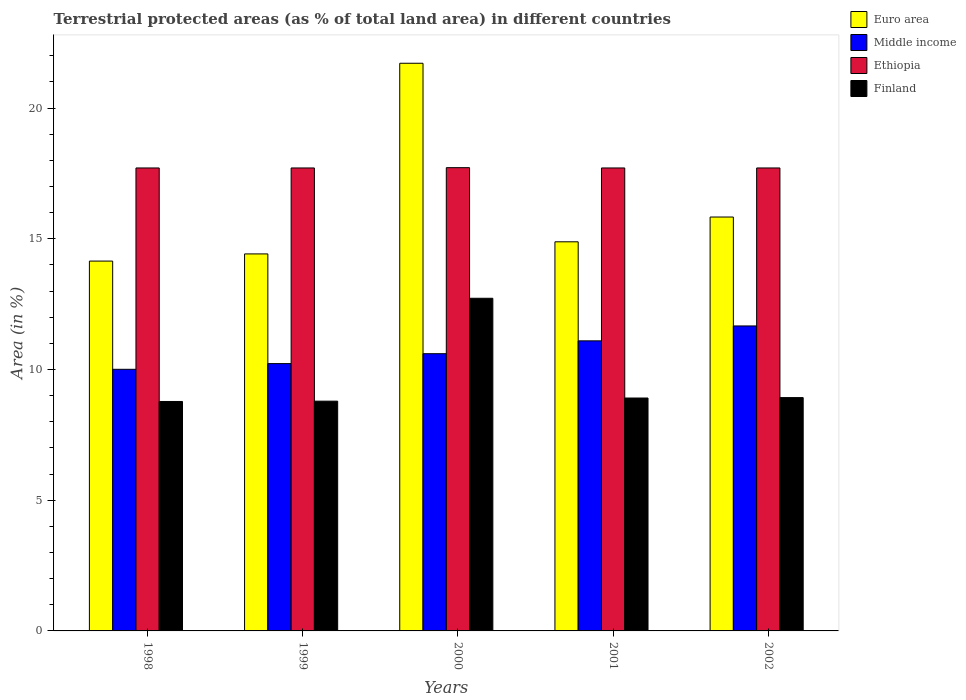How many different coloured bars are there?
Provide a short and direct response. 4. Are the number of bars on each tick of the X-axis equal?
Make the answer very short. Yes. How many bars are there on the 4th tick from the right?
Ensure brevity in your answer.  4. In how many cases, is the number of bars for a given year not equal to the number of legend labels?
Provide a short and direct response. 0. What is the percentage of terrestrial protected land in Ethiopia in 2002?
Provide a succinct answer. 17.71. Across all years, what is the maximum percentage of terrestrial protected land in Middle income?
Offer a terse response. 11.67. Across all years, what is the minimum percentage of terrestrial protected land in Finland?
Offer a terse response. 8.78. In which year was the percentage of terrestrial protected land in Middle income minimum?
Provide a short and direct response. 1998. What is the total percentage of terrestrial protected land in Ethiopia in the graph?
Ensure brevity in your answer.  88.57. What is the difference between the percentage of terrestrial protected land in Ethiopia in 2000 and that in 2002?
Your answer should be very brief. 0.01. What is the difference between the percentage of terrestrial protected land in Ethiopia in 2001 and the percentage of terrestrial protected land in Finland in 2002?
Keep it short and to the point. 8.79. What is the average percentage of terrestrial protected land in Ethiopia per year?
Give a very brief answer. 17.71. In the year 2001, what is the difference between the percentage of terrestrial protected land in Middle income and percentage of terrestrial protected land in Euro area?
Give a very brief answer. -3.79. In how many years, is the percentage of terrestrial protected land in Finland greater than 3 %?
Provide a short and direct response. 5. What is the ratio of the percentage of terrestrial protected land in Middle income in 1998 to that in 2002?
Your answer should be very brief. 0.86. Is the percentage of terrestrial protected land in Euro area in 1998 less than that in 2001?
Your answer should be compact. Yes. Is the difference between the percentage of terrestrial protected land in Middle income in 1999 and 2001 greater than the difference between the percentage of terrestrial protected land in Euro area in 1999 and 2001?
Ensure brevity in your answer.  No. What is the difference between the highest and the second highest percentage of terrestrial protected land in Finland?
Your response must be concise. 3.8. What is the difference between the highest and the lowest percentage of terrestrial protected land in Ethiopia?
Offer a very short reply. 0.01. Is it the case that in every year, the sum of the percentage of terrestrial protected land in Ethiopia and percentage of terrestrial protected land in Euro area is greater than the sum of percentage of terrestrial protected land in Middle income and percentage of terrestrial protected land in Finland?
Offer a very short reply. Yes. What does the 4th bar from the left in 1998 represents?
Provide a succinct answer. Finland. Are all the bars in the graph horizontal?
Make the answer very short. No. How many years are there in the graph?
Keep it short and to the point. 5. Does the graph contain any zero values?
Provide a succinct answer. No. Does the graph contain grids?
Your answer should be very brief. No. Where does the legend appear in the graph?
Give a very brief answer. Top right. How many legend labels are there?
Provide a succinct answer. 4. How are the legend labels stacked?
Ensure brevity in your answer.  Vertical. What is the title of the graph?
Your answer should be very brief. Terrestrial protected areas (as % of total land area) in different countries. Does "Slovenia" appear as one of the legend labels in the graph?
Keep it short and to the point. No. What is the label or title of the X-axis?
Offer a very short reply. Years. What is the label or title of the Y-axis?
Your answer should be very brief. Area (in %). What is the Area (in %) of Euro area in 1998?
Your answer should be very brief. 14.15. What is the Area (in %) of Middle income in 1998?
Make the answer very short. 10.01. What is the Area (in %) of Ethiopia in 1998?
Provide a succinct answer. 17.71. What is the Area (in %) of Finland in 1998?
Offer a very short reply. 8.78. What is the Area (in %) in Euro area in 1999?
Make the answer very short. 14.42. What is the Area (in %) in Middle income in 1999?
Keep it short and to the point. 10.23. What is the Area (in %) in Ethiopia in 1999?
Provide a succinct answer. 17.71. What is the Area (in %) of Finland in 1999?
Your answer should be compact. 8.79. What is the Area (in %) of Euro area in 2000?
Offer a terse response. 21.72. What is the Area (in %) in Middle income in 2000?
Make the answer very short. 10.61. What is the Area (in %) of Ethiopia in 2000?
Offer a terse response. 17.72. What is the Area (in %) in Finland in 2000?
Give a very brief answer. 12.73. What is the Area (in %) in Euro area in 2001?
Your response must be concise. 14.89. What is the Area (in %) of Middle income in 2001?
Your answer should be very brief. 11.1. What is the Area (in %) in Ethiopia in 2001?
Ensure brevity in your answer.  17.71. What is the Area (in %) in Finland in 2001?
Give a very brief answer. 8.91. What is the Area (in %) in Euro area in 2002?
Offer a terse response. 15.83. What is the Area (in %) of Middle income in 2002?
Keep it short and to the point. 11.67. What is the Area (in %) in Ethiopia in 2002?
Ensure brevity in your answer.  17.71. What is the Area (in %) of Finland in 2002?
Ensure brevity in your answer.  8.93. Across all years, what is the maximum Area (in %) of Euro area?
Ensure brevity in your answer.  21.72. Across all years, what is the maximum Area (in %) of Middle income?
Your response must be concise. 11.67. Across all years, what is the maximum Area (in %) in Ethiopia?
Offer a very short reply. 17.72. Across all years, what is the maximum Area (in %) of Finland?
Your response must be concise. 12.73. Across all years, what is the minimum Area (in %) of Euro area?
Keep it short and to the point. 14.15. Across all years, what is the minimum Area (in %) in Middle income?
Keep it short and to the point. 10.01. Across all years, what is the minimum Area (in %) in Ethiopia?
Provide a short and direct response. 17.71. Across all years, what is the minimum Area (in %) in Finland?
Your answer should be compact. 8.78. What is the total Area (in %) of Euro area in the graph?
Give a very brief answer. 81.01. What is the total Area (in %) in Middle income in the graph?
Provide a short and direct response. 53.6. What is the total Area (in %) in Ethiopia in the graph?
Make the answer very short. 88.57. What is the total Area (in %) of Finland in the graph?
Offer a terse response. 48.13. What is the difference between the Area (in %) of Euro area in 1998 and that in 1999?
Give a very brief answer. -0.27. What is the difference between the Area (in %) in Middle income in 1998 and that in 1999?
Give a very brief answer. -0.22. What is the difference between the Area (in %) in Ethiopia in 1998 and that in 1999?
Your response must be concise. 0. What is the difference between the Area (in %) in Finland in 1998 and that in 1999?
Ensure brevity in your answer.  -0.01. What is the difference between the Area (in %) of Euro area in 1998 and that in 2000?
Offer a very short reply. -7.57. What is the difference between the Area (in %) of Middle income in 1998 and that in 2000?
Provide a short and direct response. -0.6. What is the difference between the Area (in %) of Ethiopia in 1998 and that in 2000?
Provide a succinct answer. -0.01. What is the difference between the Area (in %) in Finland in 1998 and that in 2000?
Give a very brief answer. -3.95. What is the difference between the Area (in %) of Euro area in 1998 and that in 2001?
Your answer should be very brief. -0.74. What is the difference between the Area (in %) of Middle income in 1998 and that in 2001?
Provide a succinct answer. -1.09. What is the difference between the Area (in %) of Ethiopia in 1998 and that in 2001?
Ensure brevity in your answer.  0. What is the difference between the Area (in %) of Finland in 1998 and that in 2001?
Keep it short and to the point. -0.13. What is the difference between the Area (in %) of Euro area in 1998 and that in 2002?
Provide a short and direct response. -1.69. What is the difference between the Area (in %) of Middle income in 1998 and that in 2002?
Ensure brevity in your answer.  -1.66. What is the difference between the Area (in %) in Ethiopia in 1998 and that in 2002?
Provide a succinct answer. 0. What is the difference between the Area (in %) in Finland in 1998 and that in 2002?
Make the answer very short. -0.15. What is the difference between the Area (in %) of Euro area in 1999 and that in 2000?
Provide a succinct answer. -7.29. What is the difference between the Area (in %) of Middle income in 1999 and that in 2000?
Keep it short and to the point. -0.38. What is the difference between the Area (in %) of Ethiopia in 1999 and that in 2000?
Offer a very short reply. -0.01. What is the difference between the Area (in %) in Finland in 1999 and that in 2000?
Your answer should be very brief. -3.94. What is the difference between the Area (in %) of Euro area in 1999 and that in 2001?
Ensure brevity in your answer.  -0.46. What is the difference between the Area (in %) in Middle income in 1999 and that in 2001?
Offer a terse response. -0.87. What is the difference between the Area (in %) of Ethiopia in 1999 and that in 2001?
Provide a succinct answer. 0. What is the difference between the Area (in %) of Finland in 1999 and that in 2001?
Offer a terse response. -0.12. What is the difference between the Area (in %) of Euro area in 1999 and that in 2002?
Your response must be concise. -1.41. What is the difference between the Area (in %) of Middle income in 1999 and that in 2002?
Provide a succinct answer. -1.44. What is the difference between the Area (in %) in Finland in 1999 and that in 2002?
Your response must be concise. -0.14. What is the difference between the Area (in %) of Euro area in 2000 and that in 2001?
Your answer should be compact. 6.83. What is the difference between the Area (in %) in Middle income in 2000 and that in 2001?
Ensure brevity in your answer.  -0.49. What is the difference between the Area (in %) of Ethiopia in 2000 and that in 2001?
Keep it short and to the point. 0.01. What is the difference between the Area (in %) in Finland in 2000 and that in 2001?
Give a very brief answer. 3.82. What is the difference between the Area (in %) in Euro area in 2000 and that in 2002?
Your answer should be very brief. 5.88. What is the difference between the Area (in %) in Middle income in 2000 and that in 2002?
Offer a very short reply. -1.06. What is the difference between the Area (in %) in Ethiopia in 2000 and that in 2002?
Provide a succinct answer. 0.01. What is the difference between the Area (in %) of Finland in 2000 and that in 2002?
Provide a succinct answer. 3.8. What is the difference between the Area (in %) of Euro area in 2001 and that in 2002?
Make the answer very short. -0.95. What is the difference between the Area (in %) in Middle income in 2001 and that in 2002?
Your answer should be compact. -0.57. What is the difference between the Area (in %) of Finland in 2001 and that in 2002?
Give a very brief answer. -0.02. What is the difference between the Area (in %) in Euro area in 1998 and the Area (in %) in Middle income in 1999?
Give a very brief answer. 3.92. What is the difference between the Area (in %) of Euro area in 1998 and the Area (in %) of Ethiopia in 1999?
Give a very brief answer. -3.56. What is the difference between the Area (in %) in Euro area in 1998 and the Area (in %) in Finland in 1999?
Keep it short and to the point. 5.36. What is the difference between the Area (in %) of Middle income in 1998 and the Area (in %) of Ethiopia in 1999?
Your response must be concise. -7.7. What is the difference between the Area (in %) of Middle income in 1998 and the Area (in %) of Finland in 1999?
Ensure brevity in your answer.  1.22. What is the difference between the Area (in %) of Ethiopia in 1998 and the Area (in %) of Finland in 1999?
Your answer should be compact. 8.92. What is the difference between the Area (in %) in Euro area in 1998 and the Area (in %) in Middle income in 2000?
Provide a short and direct response. 3.54. What is the difference between the Area (in %) in Euro area in 1998 and the Area (in %) in Ethiopia in 2000?
Make the answer very short. -3.57. What is the difference between the Area (in %) of Euro area in 1998 and the Area (in %) of Finland in 2000?
Offer a terse response. 1.42. What is the difference between the Area (in %) of Middle income in 1998 and the Area (in %) of Ethiopia in 2000?
Your answer should be very brief. -7.71. What is the difference between the Area (in %) of Middle income in 1998 and the Area (in %) of Finland in 2000?
Give a very brief answer. -2.72. What is the difference between the Area (in %) of Ethiopia in 1998 and the Area (in %) of Finland in 2000?
Your response must be concise. 4.99. What is the difference between the Area (in %) in Euro area in 1998 and the Area (in %) in Middle income in 2001?
Provide a short and direct response. 3.05. What is the difference between the Area (in %) of Euro area in 1998 and the Area (in %) of Ethiopia in 2001?
Provide a succinct answer. -3.56. What is the difference between the Area (in %) of Euro area in 1998 and the Area (in %) of Finland in 2001?
Offer a very short reply. 5.24. What is the difference between the Area (in %) in Middle income in 1998 and the Area (in %) in Ethiopia in 2001?
Your answer should be very brief. -7.7. What is the difference between the Area (in %) of Middle income in 1998 and the Area (in %) of Finland in 2001?
Your answer should be very brief. 1.1. What is the difference between the Area (in %) of Ethiopia in 1998 and the Area (in %) of Finland in 2001?
Provide a short and direct response. 8.8. What is the difference between the Area (in %) in Euro area in 1998 and the Area (in %) in Middle income in 2002?
Provide a succinct answer. 2.48. What is the difference between the Area (in %) of Euro area in 1998 and the Area (in %) of Ethiopia in 2002?
Keep it short and to the point. -3.56. What is the difference between the Area (in %) of Euro area in 1998 and the Area (in %) of Finland in 2002?
Your response must be concise. 5.22. What is the difference between the Area (in %) in Middle income in 1998 and the Area (in %) in Ethiopia in 2002?
Ensure brevity in your answer.  -7.7. What is the difference between the Area (in %) of Middle income in 1998 and the Area (in %) of Finland in 2002?
Make the answer very short. 1.08. What is the difference between the Area (in %) of Ethiopia in 1998 and the Area (in %) of Finland in 2002?
Give a very brief answer. 8.79. What is the difference between the Area (in %) of Euro area in 1999 and the Area (in %) of Middle income in 2000?
Offer a very short reply. 3.82. What is the difference between the Area (in %) in Euro area in 1999 and the Area (in %) in Ethiopia in 2000?
Offer a terse response. -3.3. What is the difference between the Area (in %) of Euro area in 1999 and the Area (in %) of Finland in 2000?
Provide a succinct answer. 1.7. What is the difference between the Area (in %) of Middle income in 1999 and the Area (in %) of Ethiopia in 2000?
Offer a terse response. -7.5. What is the difference between the Area (in %) of Middle income in 1999 and the Area (in %) of Finland in 2000?
Provide a short and direct response. -2.5. What is the difference between the Area (in %) of Ethiopia in 1999 and the Area (in %) of Finland in 2000?
Give a very brief answer. 4.99. What is the difference between the Area (in %) of Euro area in 1999 and the Area (in %) of Middle income in 2001?
Offer a very short reply. 3.33. What is the difference between the Area (in %) of Euro area in 1999 and the Area (in %) of Ethiopia in 2001?
Provide a short and direct response. -3.29. What is the difference between the Area (in %) in Euro area in 1999 and the Area (in %) in Finland in 2001?
Ensure brevity in your answer.  5.51. What is the difference between the Area (in %) in Middle income in 1999 and the Area (in %) in Ethiopia in 2001?
Ensure brevity in your answer.  -7.48. What is the difference between the Area (in %) in Middle income in 1999 and the Area (in %) in Finland in 2001?
Your answer should be very brief. 1.32. What is the difference between the Area (in %) in Ethiopia in 1999 and the Area (in %) in Finland in 2001?
Ensure brevity in your answer.  8.8. What is the difference between the Area (in %) in Euro area in 1999 and the Area (in %) in Middle income in 2002?
Provide a short and direct response. 2.76. What is the difference between the Area (in %) of Euro area in 1999 and the Area (in %) of Ethiopia in 2002?
Offer a very short reply. -3.29. What is the difference between the Area (in %) of Euro area in 1999 and the Area (in %) of Finland in 2002?
Your answer should be compact. 5.5. What is the difference between the Area (in %) in Middle income in 1999 and the Area (in %) in Ethiopia in 2002?
Ensure brevity in your answer.  -7.48. What is the difference between the Area (in %) of Middle income in 1999 and the Area (in %) of Finland in 2002?
Provide a short and direct response. 1.3. What is the difference between the Area (in %) in Ethiopia in 1999 and the Area (in %) in Finland in 2002?
Offer a very short reply. 8.79. What is the difference between the Area (in %) of Euro area in 2000 and the Area (in %) of Middle income in 2001?
Ensure brevity in your answer.  10.62. What is the difference between the Area (in %) in Euro area in 2000 and the Area (in %) in Ethiopia in 2001?
Provide a succinct answer. 4.01. What is the difference between the Area (in %) in Euro area in 2000 and the Area (in %) in Finland in 2001?
Ensure brevity in your answer.  12.81. What is the difference between the Area (in %) of Middle income in 2000 and the Area (in %) of Ethiopia in 2001?
Your answer should be very brief. -7.11. What is the difference between the Area (in %) of Middle income in 2000 and the Area (in %) of Finland in 2001?
Provide a short and direct response. 1.7. What is the difference between the Area (in %) in Ethiopia in 2000 and the Area (in %) in Finland in 2001?
Make the answer very short. 8.81. What is the difference between the Area (in %) of Euro area in 2000 and the Area (in %) of Middle income in 2002?
Keep it short and to the point. 10.05. What is the difference between the Area (in %) of Euro area in 2000 and the Area (in %) of Ethiopia in 2002?
Give a very brief answer. 4.01. What is the difference between the Area (in %) of Euro area in 2000 and the Area (in %) of Finland in 2002?
Ensure brevity in your answer.  12.79. What is the difference between the Area (in %) in Middle income in 2000 and the Area (in %) in Ethiopia in 2002?
Your answer should be very brief. -7.11. What is the difference between the Area (in %) of Middle income in 2000 and the Area (in %) of Finland in 2002?
Keep it short and to the point. 1.68. What is the difference between the Area (in %) in Ethiopia in 2000 and the Area (in %) in Finland in 2002?
Offer a terse response. 8.8. What is the difference between the Area (in %) of Euro area in 2001 and the Area (in %) of Middle income in 2002?
Give a very brief answer. 3.22. What is the difference between the Area (in %) of Euro area in 2001 and the Area (in %) of Ethiopia in 2002?
Offer a terse response. -2.83. What is the difference between the Area (in %) in Euro area in 2001 and the Area (in %) in Finland in 2002?
Your answer should be compact. 5.96. What is the difference between the Area (in %) of Middle income in 2001 and the Area (in %) of Ethiopia in 2002?
Your response must be concise. -6.61. What is the difference between the Area (in %) in Middle income in 2001 and the Area (in %) in Finland in 2002?
Give a very brief answer. 2.17. What is the difference between the Area (in %) in Ethiopia in 2001 and the Area (in %) in Finland in 2002?
Make the answer very short. 8.79. What is the average Area (in %) in Euro area per year?
Make the answer very short. 16.2. What is the average Area (in %) in Middle income per year?
Offer a very short reply. 10.72. What is the average Area (in %) in Ethiopia per year?
Your answer should be very brief. 17.71. What is the average Area (in %) in Finland per year?
Provide a succinct answer. 9.63. In the year 1998, what is the difference between the Area (in %) in Euro area and Area (in %) in Middle income?
Your answer should be compact. 4.14. In the year 1998, what is the difference between the Area (in %) of Euro area and Area (in %) of Ethiopia?
Ensure brevity in your answer.  -3.56. In the year 1998, what is the difference between the Area (in %) of Euro area and Area (in %) of Finland?
Offer a very short reply. 5.37. In the year 1998, what is the difference between the Area (in %) in Middle income and Area (in %) in Ethiopia?
Offer a very short reply. -7.7. In the year 1998, what is the difference between the Area (in %) in Middle income and Area (in %) in Finland?
Offer a very short reply. 1.23. In the year 1998, what is the difference between the Area (in %) in Ethiopia and Area (in %) in Finland?
Provide a short and direct response. 8.93. In the year 1999, what is the difference between the Area (in %) in Euro area and Area (in %) in Middle income?
Provide a succinct answer. 4.2. In the year 1999, what is the difference between the Area (in %) in Euro area and Area (in %) in Ethiopia?
Your answer should be very brief. -3.29. In the year 1999, what is the difference between the Area (in %) in Euro area and Area (in %) in Finland?
Make the answer very short. 5.63. In the year 1999, what is the difference between the Area (in %) of Middle income and Area (in %) of Ethiopia?
Provide a short and direct response. -7.48. In the year 1999, what is the difference between the Area (in %) of Middle income and Area (in %) of Finland?
Keep it short and to the point. 1.44. In the year 1999, what is the difference between the Area (in %) in Ethiopia and Area (in %) in Finland?
Provide a short and direct response. 8.92. In the year 2000, what is the difference between the Area (in %) of Euro area and Area (in %) of Middle income?
Your response must be concise. 11.11. In the year 2000, what is the difference between the Area (in %) in Euro area and Area (in %) in Ethiopia?
Your answer should be very brief. 3.99. In the year 2000, what is the difference between the Area (in %) in Euro area and Area (in %) in Finland?
Provide a short and direct response. 8.99. In the year 2000, what is the difference between the Area (in %) of Middle income and Area (in %) of Ethiopia?
Provide a short and direct response. -7.12. In the year 2000, what is the difference between the Area (in %) of Middle income and Area (in %) of Finland?
Your response must be concise. -2.12. In the year 2000, what is the difference between the Area (in %) of Ethiopia and Area (in %) of Finland?
Provide a succinct answer. 5. In the year 2001, what is the difference between the Area (in %) in Euro area and Area (in %) in Middle income?
Offer a terse response. 3.79. In the year 2001, what is the difference between the Area (in %) in Euro area and Area (in %) in Ethiopia?
Give a very brief answer. -2.83. In the year 2001, what is the difference between the Area (in %) of Euro area and Area (in %) of Finland?
Keep it short and to the point. 5.98. In the year 2001, what is the difference between the Area (in %) of Middle income and Area (in %) of Ethiopia?
Your response must be concise. -6.61. In the year 2001, what is the difference between the Area (in %) of Middle income and Area (in %) of Finland?
Keep it short and to the point. 2.19. In the year 2001, what is the difference between the Area (in %) in Ethiopia and Area (in %) in Finland?
Make the answer very short. 8.8. In the year 2002, what is the difference between the Area (in %) in Euro area and Area (in %) in Middle income?
Your response must be concise. 4.17. In the year 2002, what is the difference between the Area (in %) in Euro area and Area (in %) in Ethiopia?
Give a very brief answer. -1.88. In the year 2002, what is the difference between the Area (in %) of Euro area and Area (in %) of Finland?
Provide a short and direct response. 6.91. In the year 2002, what is the difference between the Area (in %) in Middle income and Area (in %) in Ethiopia?
Ensure brevity in your answer.  -6.04. In the year 2002, what is the difference between the Area (in %) in Middle income and Area (in %) in Finland?
Offer a terse response. 2.74. In the year 2002, what is the difference between the Area (in %) in Ethiopia and Area (in %) in Finland?
Ensure brevity in your answer.  8.79. What is the ratio of the Area (in %) of Middle income in 1998 to that in 1999?
Your answer should be compact. 0.98. What is the ratio of the Area (in %) of Finland in 1998 to that in 1999?
Your response must be concise. 1. What is the ratio of the Area (in %) in Euro area in 1998 to that in 2000?
Ensure brevity in your answer.  0.65. What is the ratio of the Area (in %) in Middle income in 1998 to that in 2000?
Keep it short and to the point. 0.94. What is the ratio of the Area (in %) of Ethiopia in 1998 to that in 2000?
Ensure brevity in your answer.  1. What is the ratio of the Area (in %) in Finland in 1998 to that in 2000?
Keep it short and to the point. 0.69. What is the ratio of the Area (in %) in Euro area in 1998 to that in 2001?
Make the answer very short. 0.95. What is the ratio of the Area (in %) in Middle income in 1998 to that in 2001?
Offer a terse response. 0.9. What is the ratio of the Area (in %) in Finland in 1998 to that in 2001?
Make the answer very short. 0.99. What is the ratio of the Area (in %) of Euro area in 1998 to that in 2002?
Your answer should be very brief. 0.89. What is the ratio of the Area (in %) in Middle income in 1998 to that in 2002?
Your answer should be compact. 0.86. What is the ratio of the Area (in %) in Ethiopia in 1998 to that in 2002?
Provide a short and direct response. 1. What is the ratio of the Area (in %) of Finland in 1998 to that in 2002?
Your answer should be compact. 0.98. What is the ratio of the Area (in %) of Euro area in 1999 to that in 2000?
Ensure brevity in your answer.  0.66. What is the ratio of the Area (in %) in Middle income in 1999 to that in 2000?
Your answer should be very brief. 0.96. What is the ratio of the Area (in %) of Finland in 1999 to that in 2000?
Ensure brevity in your answer.  0.69. What is the ratio of the Area (in %) of Euro area in 1999 to that in 2001?
Your answer should be compact. 0.97. What is the ratio of the Area (in %) in Middle income in 1999 to that in 2001?
Your answer should be very brief. 0.92. What is the ratio of the Area (in %) of Finland in 1999 to that in 2001?
Keep it short and to the point. 0.99. What is the ratio of the Area (in %) of Euro area in 1999 to that in 2002?
Your response must be concise. 0.91. What is the ratio of the Area (in %) of Middle income in 1999 to that in 2002?
Give a very brief answer. 0.88. What is the ratio of the Area (in %) in Ethiopia in 1999 to that in 2002?
Offer a very short reply. 1. What is the ratio of the Area (in %) in Euro area in 2000 to that in 2001?
Your response must be concise. 1.46. What is the ratio of the Area (in %) in Middle income in 2000 to that in 2001?
Offer a very short reply. 0.96. What is the ratio of the Area (in %) in Finland in 2000 to that in 2001?
Keep it short and to the point. 1.43. What is the ratio of the Area (in %) of Euro area in 2000 to that in 2002?
Provide a short and direct response. 1.37. What is the ratio of the Area (in %) of Middle income in 2000 to that in 2002?
Your answer should be very brief. 0.91. What is the ratio of the Area (in %) in Finland in 2000 to that in 2002?
Your response must be concise. 1.43. What is the ratio of the Area (in %) of Euro area in 2001 to that in 2002?
Your response must be concise. 0.94. What is the ratio of the Area (in %) in Middle income in 2001 to that in 2002?
Your answer should be very brief. 0.95. What is the ratio of the Area (in %) of Ethiopia in 2001 to that in 2002?
Keep it short and to the point. 1. What is the difference between the highest and the second highest Area (in %) in Euro area?
Provide a short and direct response. 5.88. What is the difference between the highest and the second highest Area (in %) of Middle income?
Offer a terse response. 0.57. What is the difference between the highest and the second highest Area (in %) of Ethiopia?
Offer a very short reply. 0.01. What is the difference between the highest and the second highest Area (in %) in Finland?
Offer a terse response. 3.8. What is the difference between the highest and the lowest Area (in %) of Euro area?
Provide a short and direct response. 7.57. What is the difference between the highest and the lowest Area (in %) of Middle income?
Ensure brevity in your answer.  1.66. What is the difference between the highest and the lowest Area (in %) in Ethiopia?
Make the answer very short. 0.01. What is the difference between the highest and the lowest Area (in %) in Finland?
Provide a short and direct response. 3.95. 